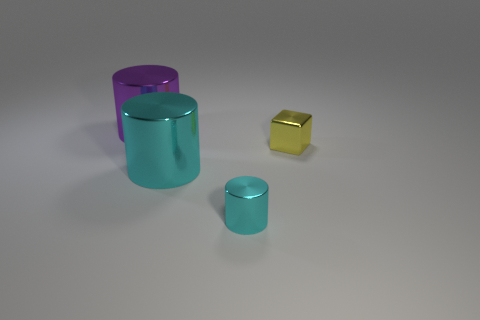What is the size of the metal block behind the small cyan metal cylinder?
Provide a succinct answer. Small. How big is the purple object?
Keep it short and to the point. Large. There is a cylinder in front of the cyan shiny cylinder to the left of the cyan cylinder that is in front of the big cyan shiny cylinder; how big is it?
Your answer should be very brief. Small. Are there any small green cubes made of the same material as the big purple cylinder?
Make the answer very short. No. What shape is the big purple object?
Your answer should be very brief. Cylinder. There is a small object that is made of the same material as the yellow block; what color is it?
Your response must be concise. Cyan. What number of purple objects are either tiny cylinders or large cylinders?
Give a very brief answer. 1. Are there more purple cylinders than small green rubber objects?
Keep it short and to the point. Yes. What number of objects are big cylinders that are behind the big cyan metallic thing or big purple cylinders behind the tiny cylinder?
Make the answer very short. 1. What is the color of the object that is the same size as the yellow metallic cube?
Offer a very short reply. Cyan. 